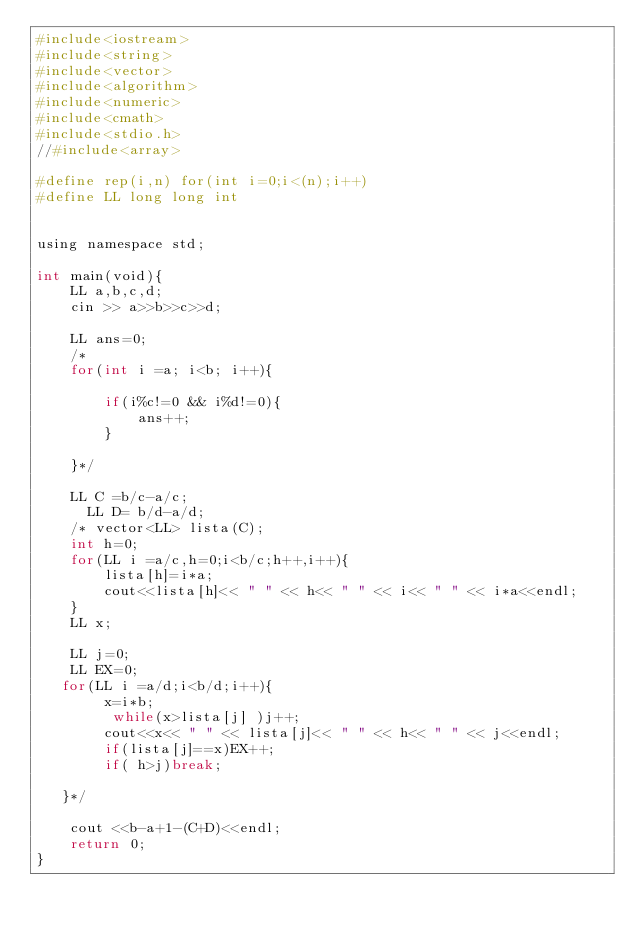Convert code to text. <code><loc_0><loc_0><loc_500><loc_500><_Python_>#include<iostream>
#include<string>
#include<vector>
#include<algorithm>
#include<numeric>
#include<cmath>
#include<stdio.h>
//#include<array>

#define rep(i,n) for(int i=0;i<(n);i++)
#define LL long long int


using namespace std;

int main(void){
    LL a,b,c,d;
    cin >> a>>b>>c>>d;

    LL ans=0;
    /* 
    for(int i =a; i<b; i++){

        if(i%c!=0 && i%d!=0){
            ans++;
        }

    }*/

    LL C =b/c-a/c;
      LL D= b/d-a/d;
    /* vector<LL> lista(C);
    int h=0;
    for(LL i =a/c,h=0;i<b/c;h++,i++){
        lista[h]=i*a;
        cout<<lista[h]<< " " << h<< " " << i<< " " << i*a<<endl;
    }
    LL x;
  
    LL j=0;
    LL EX=0;
   for(LL i =a/d;i<b/d;i++){
        x=i*b;
         while(x>lista[j] )j++;
        cout<<x<< " " << lista[j]<< " " << h<< " " << j<<endl;
        if(lista[j]==x)EX++;
        if( h>j)break;

   }*/

    cout <<b-a+1-(C+D)<<endl;
    return 0;
}</code> 